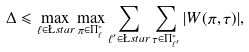<formula> <loc_0><loc_0><loc_500><loc_500>\Delta \leqslant \max _ { \ell \in \L s t a r } \max _ { \pi \in \Pi _ { \ell } ^ { * } } \sum _ { \ell ^ { \prime } \in \L s t a r } \sum _ { \tau \in \Pi _ { \ell ^ { \prime } } ^ { * } } { | W ( \pi , \tau ) | } ,</formula> 